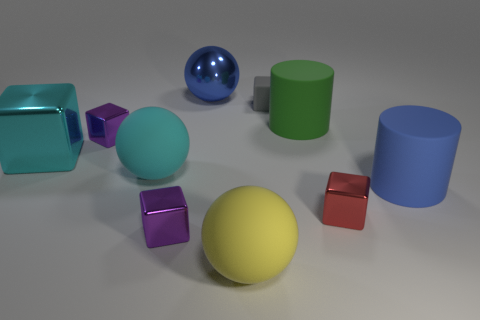Subtract all purple cylinders. How many purple blocks are left? 2 Subtract all rubber balls. How many balls are left? 1 Subtract all cyan cubes. How many cubes are left? 4 Subtract 3 cubes. How many cubes are left? 2 Subtract all cylinders. How many objects are left? 8 Add 10 small matte cylinders. How many small matte cylinders exist? 10 Subtract 0 green cubes. How many objects are left? 10 Subtract all red spheres. Subtract all brown cubes. How many spheres are left? 3 Subtract all blue spheres. Subtract all blue balls. How many objects are left? 8 Add 5 large blue metal balls. How many large blue metal balls are left? 6 